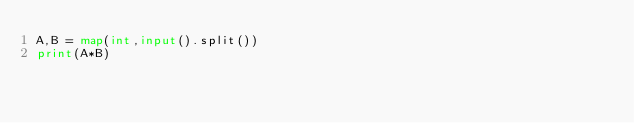<code> <loc_0><loc_0><loc_500><loc_500><_Python_>A,B = map(int,input().split())
print(A*B)</code> 